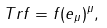<formula> <loc_0><loc_0><loc_500><loc_500>T r f = f ( e _ { \mu } ) ^ { \mu } ,</formula> 